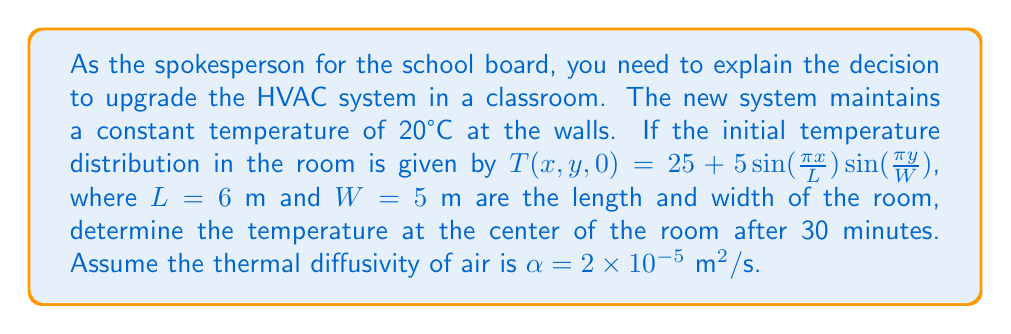Can you solve this math problem? To solve this problem, we'll use the 2D heat equation with the given initial and boundary conditions:

1) The heat equation in 2D is:
   $$\frac{\partial T}{\partial t} = \alpha \left(\frac{\partial^2 T}{\partial x^2} + \frac{\partial^2 T}{\partial y^2}\right)$$

2) The solution for this equation with the given boundary conditions is:
   $$T(x,y,t) = 20 + \sum_{m=1}^{\infty}\sum_{n=1}^{\infty} A_{mn} \sin\left(\frac{m\pi x}{L}\right)\sin\left(\frac{n\pi y}{W}\right)e^{-\alpha(\frac{m^2\pi^2}{L^2}+\frac{n^2\pi^2}{W^2})t}$$

3) From the initial condition, we can see that only the term where $m=n=1$ is non-zero:
   $$A_{11} = 5$$

4) Therefore, our solution simplifies to:
   $$T(x,y,t) = 20 + 5\sin\left(\frac{\pi x}{L}\right)\sin\left(\frac{\pi y}{W}\right)e^{-\alpha(\frac{\pi^2}{L^2}+\frac{\pi^2}{W^2})t}$$

5) At the center of the room, $x=L/2=3$ m and $y=W/2=2.5$ m. After 30 minutes, $t=1800$ s.

6) Substituting these values:
   $$T(3,2.5,1800) = 20 + 5\sin\left(\frac{\pi}{2}\right)\sin\left(\frac{\pi}{2}\right)e^{-2\times10^{-5}(\frac{\pi^2}{36}+\frac{\pi^2}{25})1800}$$

7) Simplify:
   $$T(3,2.5,1800) = 20 + 5e^{-2\times10^{-5}(\frac{\pi^2}{36}+\frac{\pi^2}{25})1800}$$

8) Calculate the exponent:
   $$-2\times10^{-5}(\frac{\pi^2}{36}+\frac{\pi^2}{25})1800 \approx -1.0944$$

9) Therefore:
   $$T(3,2.5,1800) = 20 + 5e^{-1.0944} \approx 20 + 1.67 = 21.67°C$$
Answer: 21.67°C 